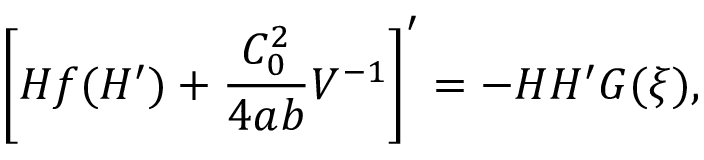<formula> <loc_0><loc_0><loc_500><loc_500>\left [ H f ( H ^ { \prime } ) + \frac { C _ { 0 } ^ { 2 } } { 4 a b } V ^ { - 1 } \right ] ^ { \prime } = - H H ^ { \prime } G ( \xi ) ,</formula> 